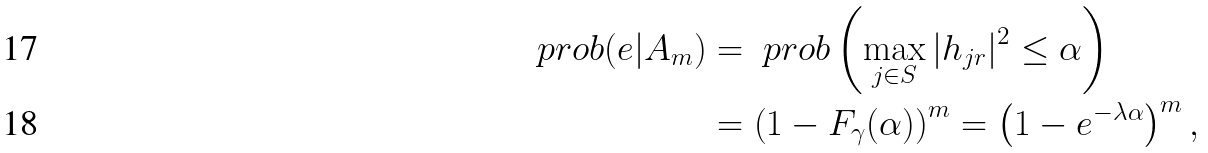<formula> <loc_0><loc_0><loc_500><loc_500>\ p r o b ( e | A _ { m } ) & = \ p r o b \left ( \max _ { j \in S } | h _ { j r } | ^ { 2 } \leq \alpha \right ) \\ & = \left ( 1 - F _ { \gamma } ( \alpha ) \right ) ^ { m } = \left ( 1 - e ^ { - \lambda \alpha } \right ) ^ { m } ,</formula> 